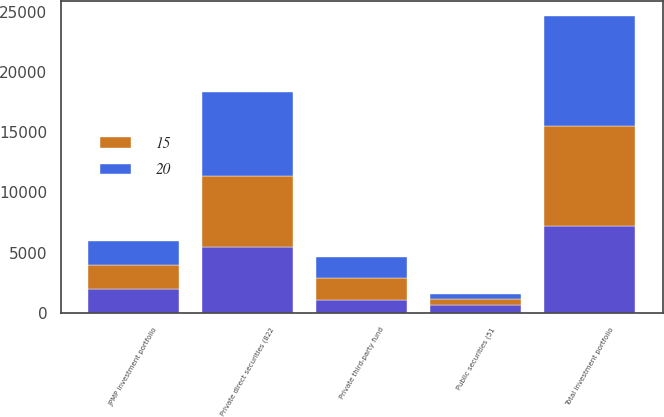Convert chart. <chart><loc_0><loc_0><loc_500><loc_500><stacked_bar_chart><ecel><fcel>JPMP investment portfolio<fcel>Public securities (51<fcel>Private direct securities (822<fcel>Private third-party fund<fcel>Total investment portfolio<nl><fcel>nan<fcel>2003<fcel>643<fcel>5508<fcel>1099<fcel>7250<nl><fcel>20<fcel>2003<fcel>451<fcel>6960<fcel>1736<fcel>9147<nl><fcel>15<fcel>2002<fcel>520<fcel>5865<fcel>1843<fcel>8228<nl></chart> 